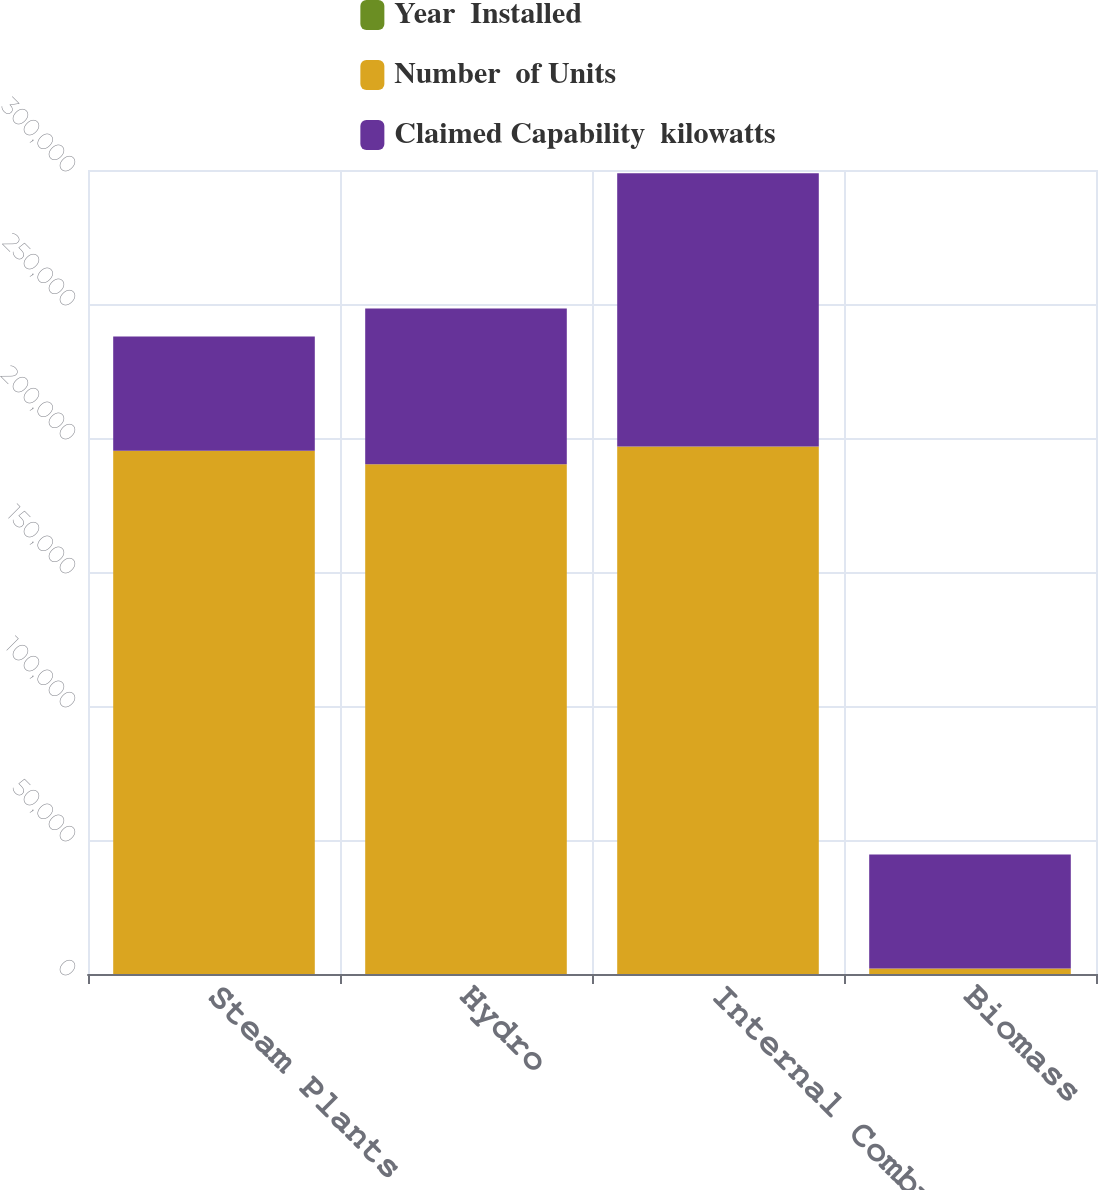Convert chart to OTSL. <chart><loc_0><loc_0><loc_500><loc_500><stacked_bar_chart><ecel><fcel>Steam Plants<fcel>Hydro<fcel>Internal Combustion<fcel>Biomass<nl><fcel>Year  Installed<fcel>5<fcel>20<fcel>5<fcel>1<nl><fcel>Number  of Units<fcel>195274<fcel>190183<fcel>196870<fcel>2006<nl><fcel>Claimed Capability  kilowatts<fcel>42594<fcel>58115<fcel>101869<fcel>42594<nl></chart> 